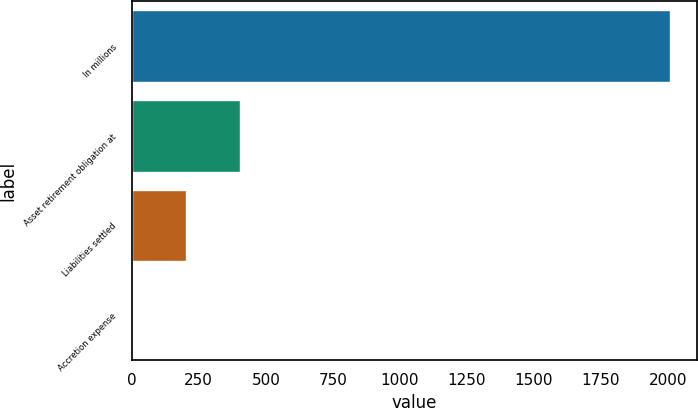<chart> <loc_0><loc_0><loc_500><loc_500><bar_chart><fcel>In millions<fcel>Asset retirement obligation at<fcel>Liabilities settled<fcel>Accretion expense<nl><fcel>2007<fcel>403<fcel>202.5<fcel>2<nl></chart> 